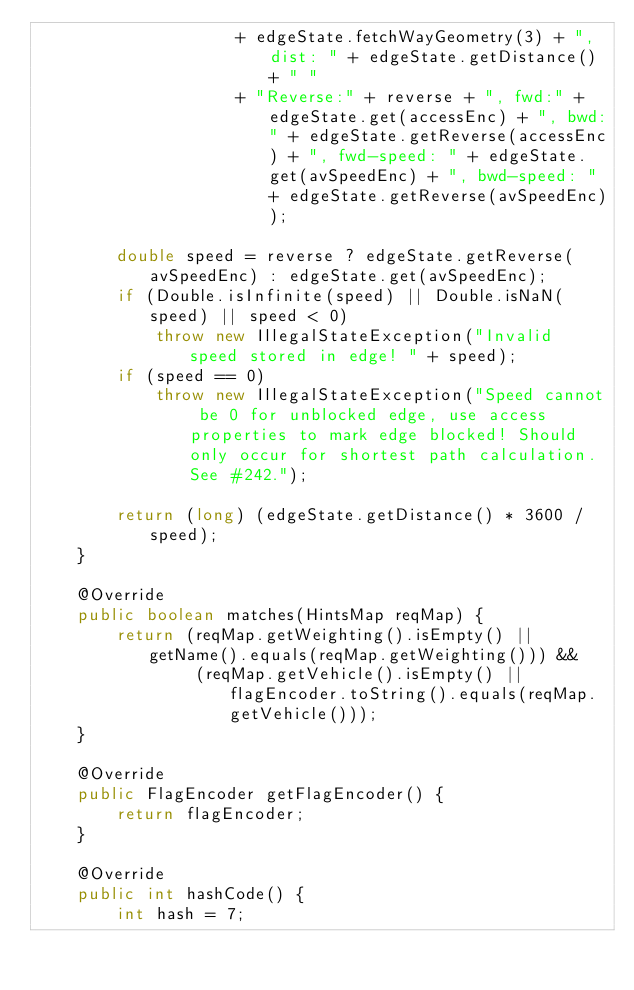<code> <loc_0><loc_0><loc_500><loc_500><_Java_>                    + edgeState.fetchWayGeometry(3) + ", dist: " + edgeState.getDistance() + " "
                    + "Reverse:" + reverse + ", fwd:" + edgeState.get(accessEnc) + ", bwd:" + edgeState.getReverse(accessEnc) + ", fwd-speed: " + edgeState.get(avSpeedEnc) + ", bwd-speed: " + edgeState.getReverse(avSpeedEnc));

        double speed = reverse ? edgeState.getReverse(avSpeedEnc) : edgeState.get(avSpeedEnc);
        if (Double.isInfinite(speed) || Double.isNaN(speed) || speed < 0)
            throw new IllegalStateException("Invalid speed stored in edge! " + speed);
        if (speed == 0)
            throw new IllegalStateException("Speed cannot be 0 for unblocked edge, use access properties to mark edge blocked! Should only occur for shortest path calculation. See #242.");

        return (long) (edgeState.getDistance() * 3600 / speed);
    }

    @Override
    public boolean matches(HintsMap reqMap) {
        return (reqMap.getWeighting().isEmpty() || getName().equals(reqMap.getWeighting())) &&
                (reqMap.getVehicle().isEmpty() || flagEncoder.toString().equals(reqMap.getVehicle()));
    }

    @Override
    public FlagEncoder getFlagEncoder() {
        return flagEncoder;
    }

    @Override
    public int hashCode() {
        int hash = 7;</code> 